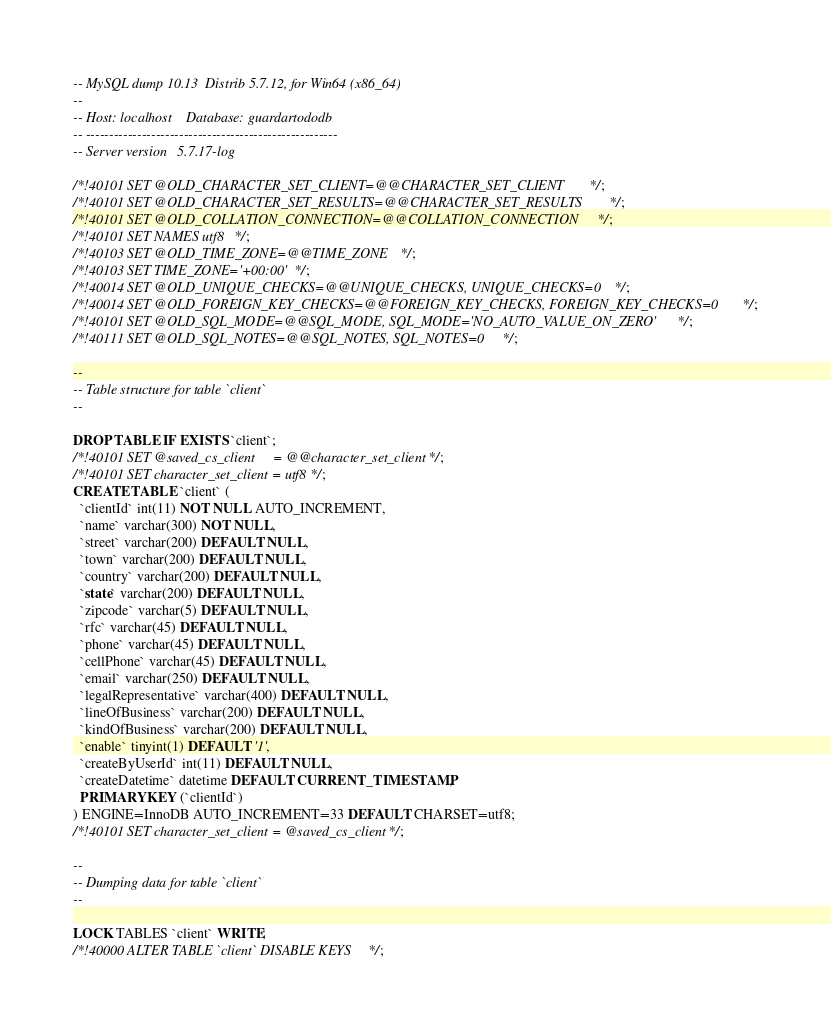Convert code to text. <code><loc_0><loc_0><loc_500><loc_500><_SQL_>-- MySQL dump 10.13  Distrib 5.7.12, for Win64 (x86_64)
--
-- Host: localhost    Database: guardartododb
-- ------------------------------------------------------
-- Server version	5.7.17-log

/*!40101 SET @OLD_CHARACTER_SET_CLIENT=@@CHARACTER_SET_CLIENT */;
/*!40101 SET @OLD_CHARACTER_SET_RESULTS=@@CHARACTER_SET_RESULTS */;
/*!40101 SET @OLD_COLLATION_CONNECTION=@@COLLATION_CONNECTION */;
/*!40101 SET NAMES utf8 */;
/*!40103 SET @OLD_TIME_ZONE=@@TIME_ZONE */;
/*!40103 SET TIME_ZONE='+00:00' */;
/*!40014 SET @OLD_UNIQUE_CHECKS=@@UNIQUE_CHECKS, UNIQUE_CHECKS=0 */;
/*!40014 SET @OLD_FOREIGN_KEY_CHECKS=@@FOREIGN_KEY_CHECKS, FOREIGN_KEY_CHECKS=0 */;
/*!40101 SET @OLD_SQL_MODE=@@SQL_MODE, SQL_MODE='NO_AUTO_VALUE_ON_ZERO' */;
/*!40111 SET @OLD_SQL_NOTES=@@SQL_NOTES, SQL_NOTES=0 */;

--
-- Table structure for table `client`
--

DROP TABLE IF EXISTS `client`;
/*!40101 SET @saved_cs_client     = @@character_set_client */;
/*!40101 SET character_set_client = utf8 */;
CREATE TABLE `client` (
  `clientId` int(11) NOT NULL AUTO_INCREMENT,
  `name` varchar(300) NOT NULL,
  `street` varchar(200) DEFAULT NULL,
  `town` varchar(200) DEFAULT NULL,
  `country` varchar(200) DEFAULT NULL,
  `state` varchar(200) DEFAULT NULL,
  `zipcode` varchar(5) DEFAULT NULL,
  `rfc` varchar(45) DEFAULT NULL,
  `phone` varchar(45) DEFAULT NULL,
  `cellPhone` varchar(45) DEFAULT NULL,
  `email` varchar(250) DEFAULT NULL,
  `legalRepresentative` varchar(400) DEFAULT NULL,
  `lineOfBusiness` varchar(200) DEFAULT NULL,
  `kindOfBusiness` varchar(200) DEFAULT NULL,
  `enable` tinyint(1) DEFAULT '1',
  `createByUserId` int(11) DEFAULT NULL,
  `createDatetime` datetime DEFAULT CURRENT_TIMESTAMP,
  PRIMARY KEY (`clientId`)
) ENGINE=InnoDB AUTO_INCREMENT=33 DEFAULT CHARSET=utf8;
/*!40101 SET character_set_client = @saved_cs_client */;

--
-- Dumping data for table `client`
--

LOCK TABLES `client` WRITE;
/*!40000 ALTER TABLE `client` DISABLE KEYS */;</code> 